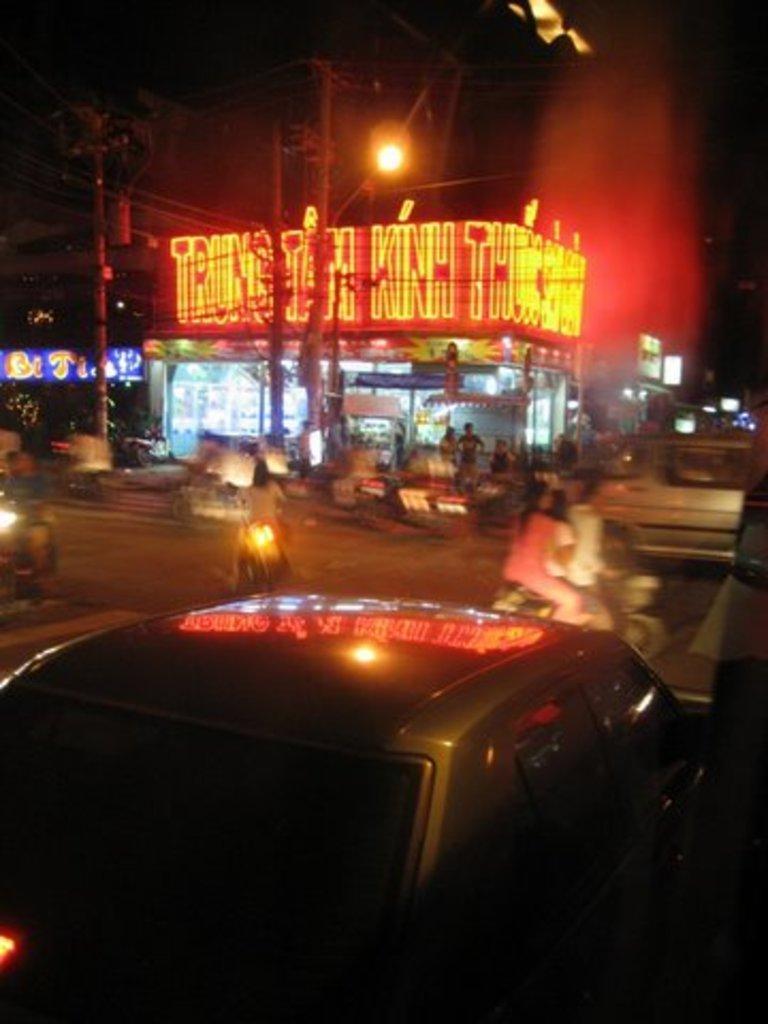Can you describe this image briefly? In this picture I can see few vehicles moving on the road and I can see couple of motorcycles and few stores with lighting text and I can see few people are standing and couple of poles and hoardings and the picture is taken in the dark. 